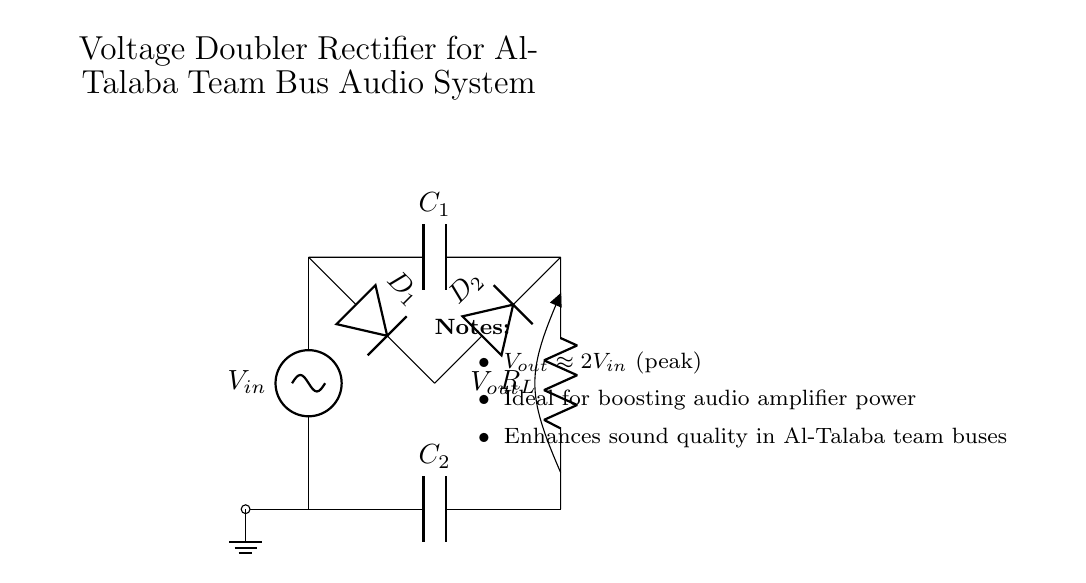what is the input voltage labeled in the circuit? The circuit diagram labels the input voltage as V_in, indicating the source of alternating current provided to the rectifier.
Answer: V_in how many diodes are in the voltage doubler rectifier circuit? The diagram clearly shows two diodes labeled as D_1 and D_2, indicating that the circuit employs two diodes for operation.
Answer: 2 what is the output voltage approximately equal to? The notes indicate that the output voltage V_out is approximately 2 times the peak input voltage, thus enhancing the output for audio amplification.
Answer: 2V_in what are the values of the capacitors used in the circuit? The circuit diagram does not provide specific numerical values for the capacitors labeled C_1 and C_2, only that they are present in the circuit for filtering.
Answer: C_1 and C_2 (no specific values) what role do the capacitors serve in this circuit? The capacitors C_1 and C_2 serve to smooth the output voltage by filtering the rectified signal, thus minimizing voltage fluctuations.
Answer: Smoothing what type of load is connected to the output of the voltage doubler circuit? The load connected to the output is indicated as R_L, suggesting that it serves as a resistor in the circuit, likely for an audio system.
Answer: R_L (resistor) 